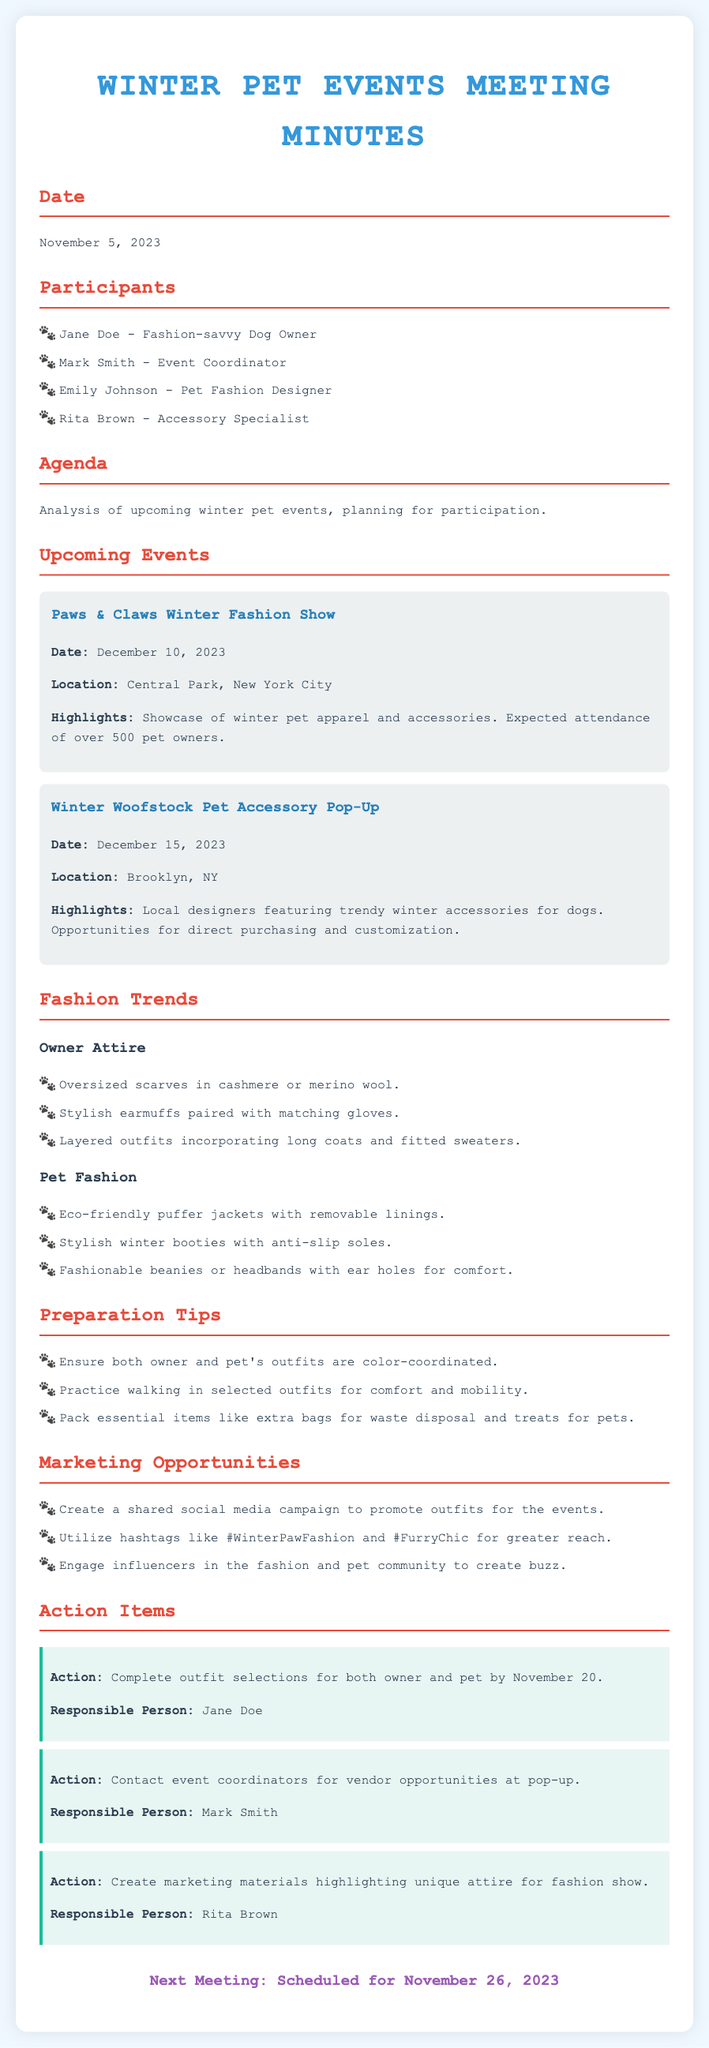what is the date of the next meeting? The next meeting is scheduled for November 26, 2023.
Answer: November 26, 2023 who is responsible for completing outfit selections? Jane Doe is noted as responsible for completing outfit selections for both owner and pet.
Answer: Jane Doe where is the Paws & Claws Winter Fashion Show taking place? The fashion show will be held at Central Park, New York City.
Answer: Central Park, New York City what are the highlights of the Winter Woofstock Pet Accessory Pop-Up? The highlights include local designers featuring trendy winter accessories for dogs.
Answer: Local designers featuring trendy winter accessories for dogs what is one of the preparation tips mentioned in the document? The document suggests ensuring both owner and pet's outfits are color-coordinated.
Answer: Ensure both owner and pet's outfits are color-coordinated how many participants were there in the meeting? There are four participants listed in the meeting minutes.
Answer: Four what sustainable trend is mentioned for pet fashion? Eco-friendly puffer jackets with removable linings are highlighted.
Answer: Eco-friendly puffer jackets with removable linings who is responsible for creating marketing materials for the fashion show? Rita Brown is tasked with creating marketing materials highlighting unique attire.
Answer: Rita Brown 